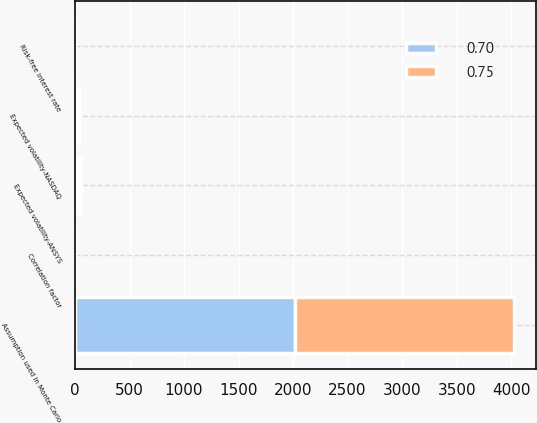Convert chart to OTSL. <chart><loc_0><loc_0><loc_500><loc_500><stacked_bar_chart><ecel><fcel>Assumption used in Monte Carlo<fcel>Risk-free interest rate<fcel>Expected volatility-ANSYS<fcel>Expected volatility-NASDAQ<fcel>Correlation factor<nl><fcel>0.7<fcel>2013<fcel>0.35<fcel>25<fcel>20<fcel>0.7<nl><fcel>0.75<fcel>2012<fcel>0.16<fcel>28<fcel>20<fcel>0.75<nl></chart> 